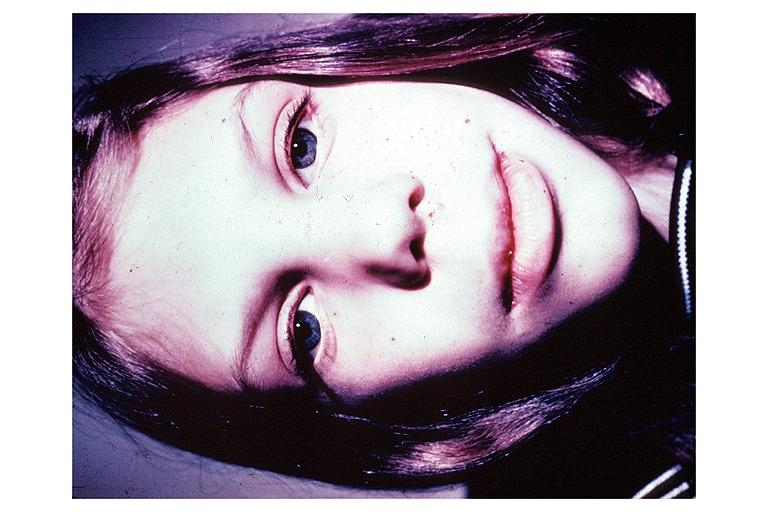what is present?
Answer the question using a single word or phrase. Oral 